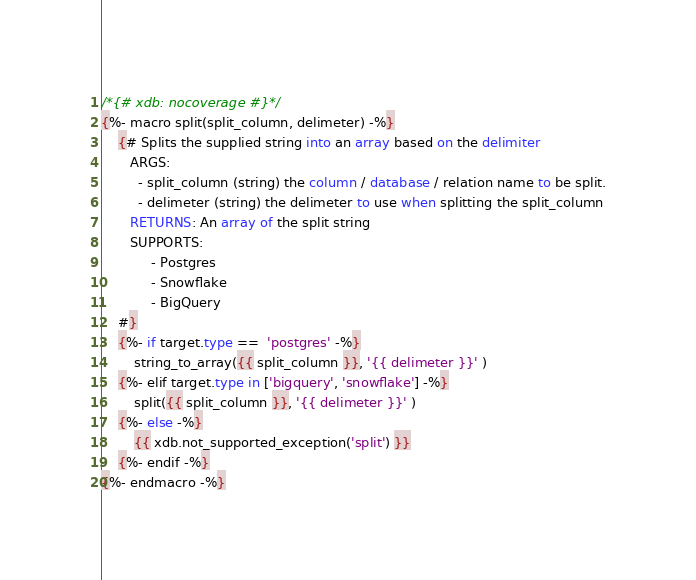<code> <loc_0><loc_0><loc_500><loc_500><_SQL_>/*{# xdb: nocoverage #}*/
{%- macro split(split_column, delimeter) -%}
    {# Splits the supplied string into an array based on the delimiter
       ARGS:
         - split_column (string) the column / database / relation name to be split.
         - delimeter (string) the delimeter to use when splitting the split_column
       RETURNS: An array of the split string
       SUPPORTS:
            - Postgres
            - Snowflake
            - BigQuery
    #}
    {%- if target.type ==  'postgres' -%} 
        string_to_array({{ split_column }}, '{{ delimeter }}' )
    {%- elif target.type in ['bigquery', 'snowflake'] -%}
        split({{ split_column }}, '{{ delimeter }}' )
    {%- else -%}
        {{ xdb.not_supported_exception('split') }}
    {%- endif -%}
{%- endmacro -%}

</code> 